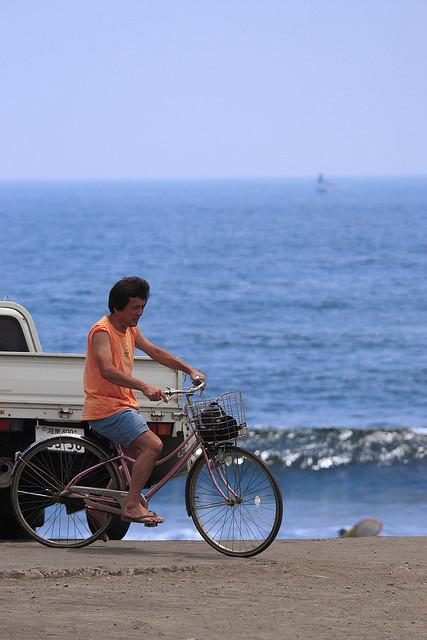What kind of power does the pink bicycle run on?

Choices:
A) coal
B) electricity
C) man power
D) gas man power 